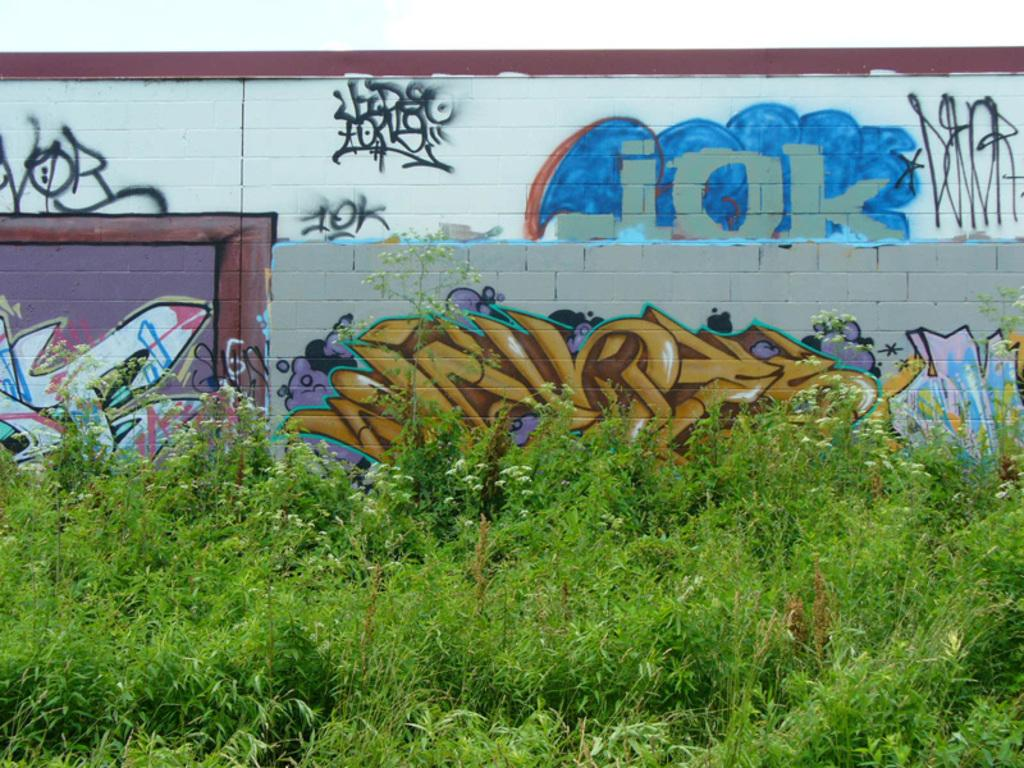What type of vegetation is at the bottom of the image? There are plants at the bottom of the image. What can be seen in the background of the image? There is a wall in the background of the image. What is on the wall in the image? There is graffiti on the wall. What type of mint can be seen growing on the wall in the image? There is no mint present in the image; the wall features graffiti instead. How can someone join the duck community in the image? There are no ducks or duck communities present in the image. 